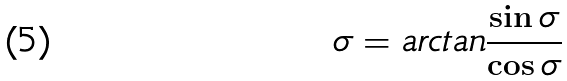Convert formula to latex. <formula><loc_0><loc_0><loc_500><loc_500>\sigma = a r c t a n \frac { \sin \sigma } { \cos \sigma }</formula> 